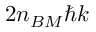<formula> <loc_0><loc_0><loc_500><loc_500>2 n _ { B M } \hbar { k }</formula> 